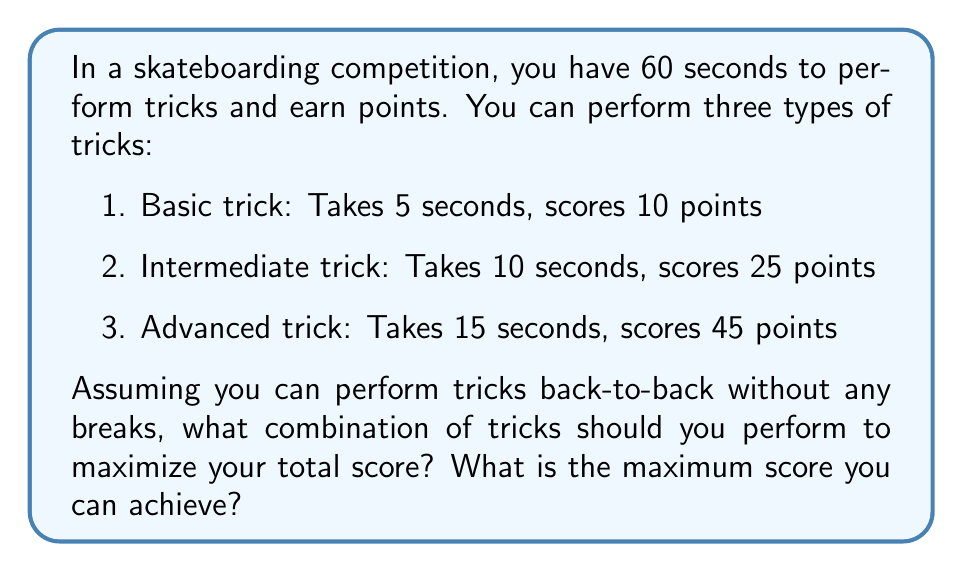Give your solution to this math problem. Let's approach this problem using game theory and optimization:

1. Define variables:
   Let $x$, $y$, and $z$ be the number of basic, intermediate, and advanced tricks respectively.

2. Set up the objective function:
   We want to maximize the total score:
   $$ \text{Score} = 10x + 25y + 45z $$

3. Establish constraints:
   The total time used must not exceed 60 seconds:
   $$ 5x + 10y + 15z \leq 60 $$
   Also, $x$, $y$, and $z$ must be non-negative integers.

4. Solve using integer programming:
   We can solve this by testing all possible combinations:

   $$(x, y, z) \in \{(12,0,0), (7,3,0), (2,6,0), (9,1,1), (4,4,1), (0,6,0), (5,2,2), (0,5,1), (1,3,2), (0,1,3), (2,1,3)\}$$

5. Calculate scores for each combination:
   $$(120, 175, 150, 145, 175, 150, 140, 170, 145, 160, 155)$$

6. Identify the maximum score:
   The maximum score is 175, which can be achieved in two ways:
   - 7 basic tricks and 3 intermediate tricks
   - 4 basic tricks, 4 intermediate tricks, and 1 advanced trick

Both strategies use exactly 60 seconds and yield the same maximum score.
Answer: The optimal strategy is to perform either:
1) 7 basic tricks and 3 intermediate tricks, or
2) 4 basic tricks, 4 intermediate tricks, and 1 advanced trick.
The maximum score achievable is 175 points. 